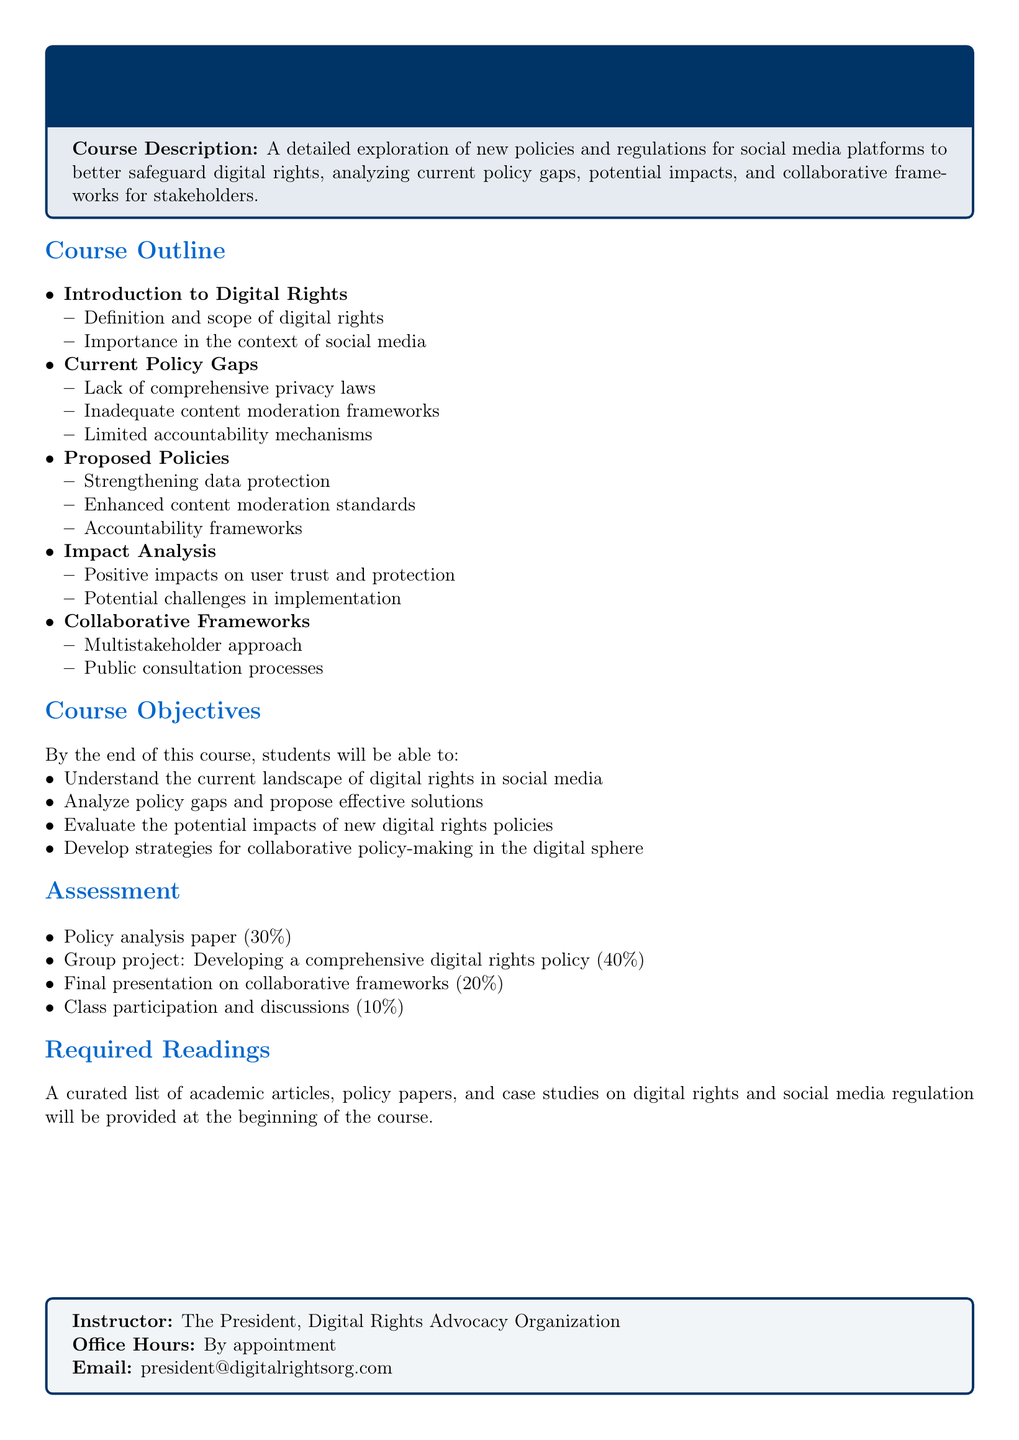What is the course title? The course title is mentioned in the document's header as part of the tcolorbox.
Answer: Social Media and Digital Rights: Policy Recommendations What percentage of the assessment is for class participation? The document specifies the weightage for each assessment component, including class participation.
Answer: 10% Who is the instructor for the course? The document clearly states the instructor's role within the provided tcolorbox.
Answer: The President, Digital Rights Advocacy Organization What is one proposed policy mentioned in the syllabus? The document lists proposed policies under a specific section, allowing for easy retrieval of this information.
Answer: Strengthening data protection What is the main focus of the course? The course description section outlines the main focus and objectives of the course.
Answer: New policies and regulations for social media platforms How many major sections are in the course outline? By counting the bullet points in the course outline, we determine the number of sections.
Answer: 5 What type of project is required in the assessment? The assessment section details the types of projects required, providing specific information on group projects.
Answer: Group project: Developing a comprehensive digital rights policy What is the total percentage of the final presentation in the assessment? The specific percentage allotted for the final presentation is stated in the assessment section of the syllabus.
Answer: 20% 